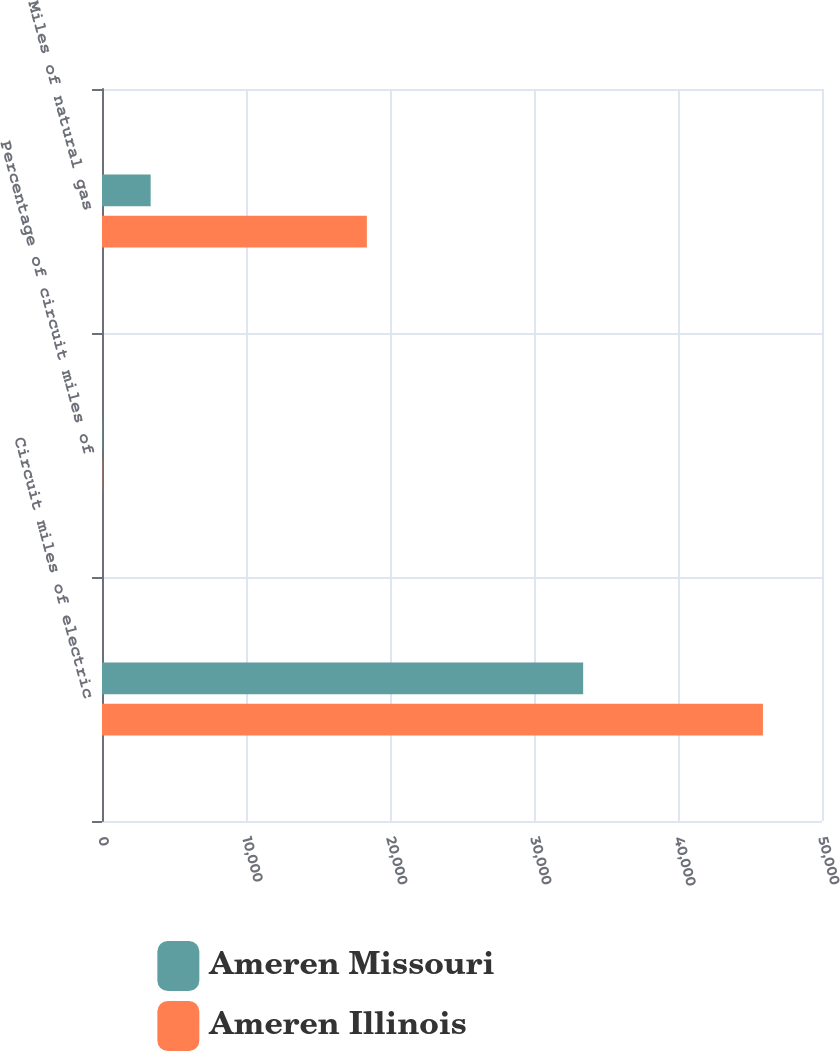Convert chart. <chart><loc_0><loc_0><loc_500><loc_500><stacked_bar_chart><ecel><fcel>Circuit miles of electric<fcel>Percentage of circuit miles of<fcel>Miles of natural gas<nl><fcel>Ameren Missouri<fcel>33414<fcel>23<fcel>3379<nl><fcel>Ameren Illinois<fcel>45899<fcel>15<fcel>18393<nl></chart> 